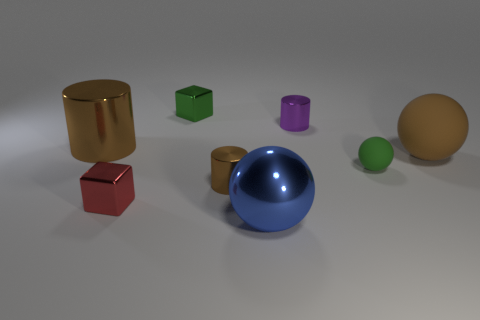What color is the big metallic cylinder?
Keep it short and to the point. Brown. Are there any metallic cylinders?
Keep it short and to the point. Yes. There is a small brown metal cylinder; are there any shiny objects in front of it?
Provide a short and direct response. Yes. There is another tiny object that is the same shape as the purple shiny thing; what is its material?
Make the answer very short. Metal. Is there any other thing that is made of the same material as the tiny red thing?
Your answer should be very brief. Yes. What number of other things are the same shape as the big brown metallic thing?
Your answer should be very brief. 2. There is a big brown thing to the right of the brown metallic cylinder that is right of the tiny green block; how many brown cylinders are left of it?
Your answer should be compact. 2. How many tiny brown things have the same shape as the blue metallic object?
Your answer should be compact. 0. There is a metallic block that is behind the small red shiny thing; is it the same color as the large rubber sphere?
Keep it short and to the point. No. There is a small rubber object that is to the right of the big shiny thing that is to the right of the object that is behind the small purple thing; what shape is it?
Make the answer very short. Sphere. 